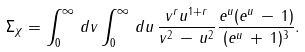<formula> <loc_0><loc_0><loc_500><loc_500>\Sigma _ { \chi } = \int _ { 0 } ^ { \infty } \, d v \int _ { 0 } ^ { \infty } \, d u \, \frac { v ^ { r } u ^ { 1 + r } } { v ^ { 2 } \, - \, u ^ { 2 } } \frac { e ^ { u } ( e ^ { u } \, - \, 1 ) } { ( e ^ { u } \, + \, 1 ) ^ { 3 } } .</formula> 